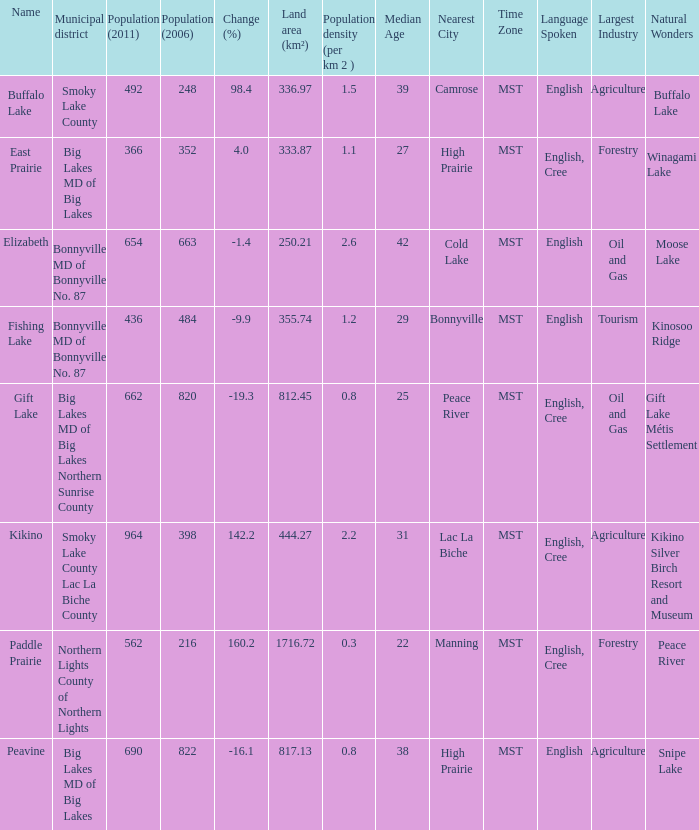What is the population density in Buffalo Lake? 1.5. 